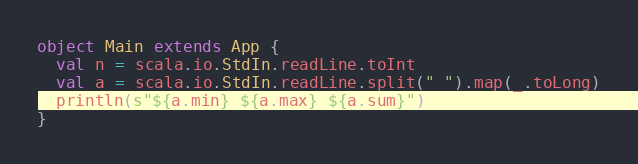<code> <loc_0><loc_0><loc_500><loc_500><_Scala_>object Main extends App {
  val n = scala.io.StdIn.readLine.toInt
  val a = scala.io.StdIn.readLine.split(" ").map(_.toLong)
  println(s"${a.min} ${a.max} ${a.sum}")
}</code> 